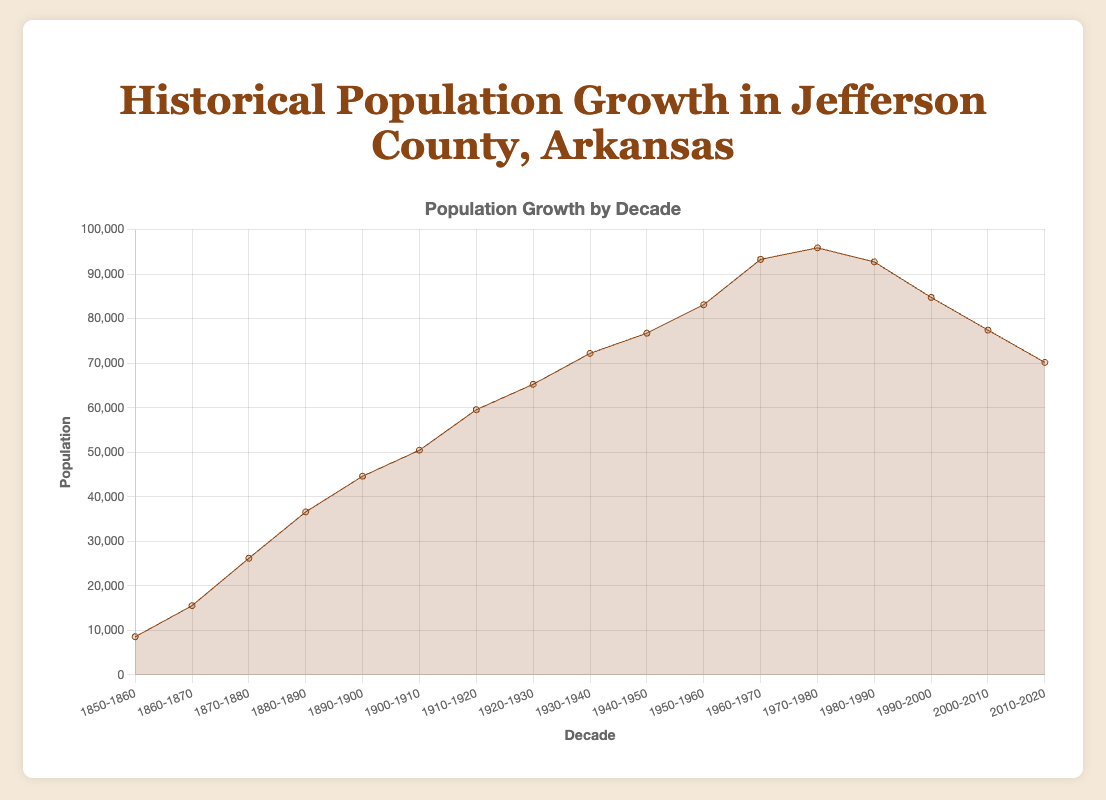What's the title of the figure? To find the title of the figure, you look at the top of the chart where the header is usually located.
Answer: Historical Population Growth in Jefferson County, Arkansas What are the labels on the x-axis and y-axis? The x-axis label indicates the categories that represent the decades, and the y-axis label indicates the numerical values which represent the population.
Answer: Decade, Population In which decade did Jefferson County experience the highest population? Identify the peak value on the area chart and find the corresponding decade on the x-axis. The highest peak of the chart is around 1970-1980.
Answer: 1970-1980 What was the population of Jefferson County in the decade 1850-1860? To find the population for the 1850-1860 decade, locate the first point on the area chart. It represents the population for that decade.
Answer: 8579 By how much did the population increase from the decade 1910-1920 to 1920-1930? Find the population values for 1910-1920 and 1920-1930 on the chart, then calculate the difference between these two values: 65272 - 59565.
Answer: 5707 Which decade saw the largest population growth compared to the previous decade? Calculate the differences between successive decades and identify the pair with the largest difference. The transition from 1860-1870 to 1870-1880 shows the largest increase: 26217 - 15560.
Answer: 1870-1880 Calculate the average population of Jefferson County over the first five decades (1850-1900). Sum the population for the decades 1850-1860, 1860-1870, 1870-1880, 1880-1890, and 1890-1900, then divide by 5: (8579 + 15560 + 26217 + 36617 + 44635) / 5.
Answer: 26522 How did the population trend change in the decade 1980-1990? Compare the population in 1980-1990 with the previous decade (1970-1980) to see if it increased or decreased: 92748 is less than 95905, indicating a decrease.
Answer: It decreased How many decades experienced a population decline compared to the previous decade? Count the number of data points where the population value is less than the value of the previous decade by examining the chart: Two declines were observed (1980-1990 and 1990-2000, and 2000-2010).
Answer: 3 